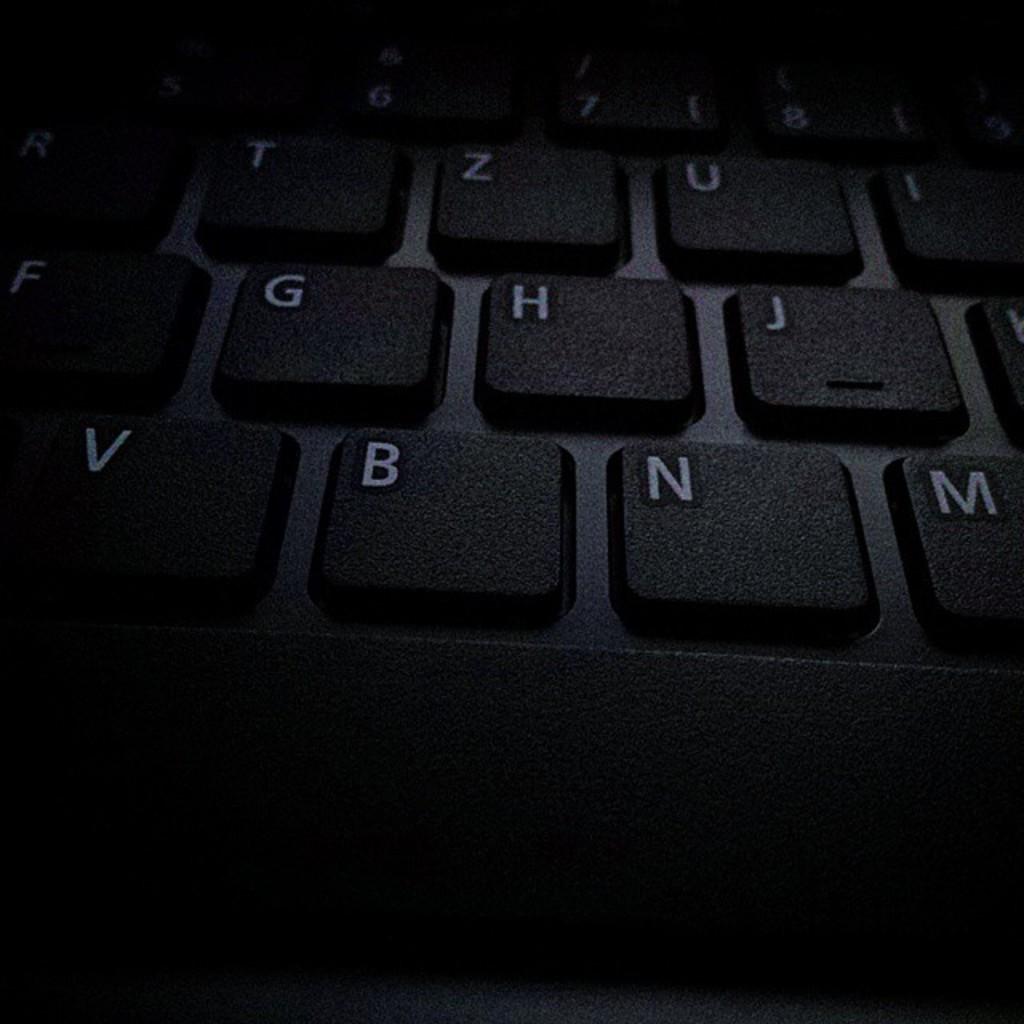Which key is to the left of n?
Offer a very short reply. B. Is the letter c visible?
Give a very brief answer. No. 